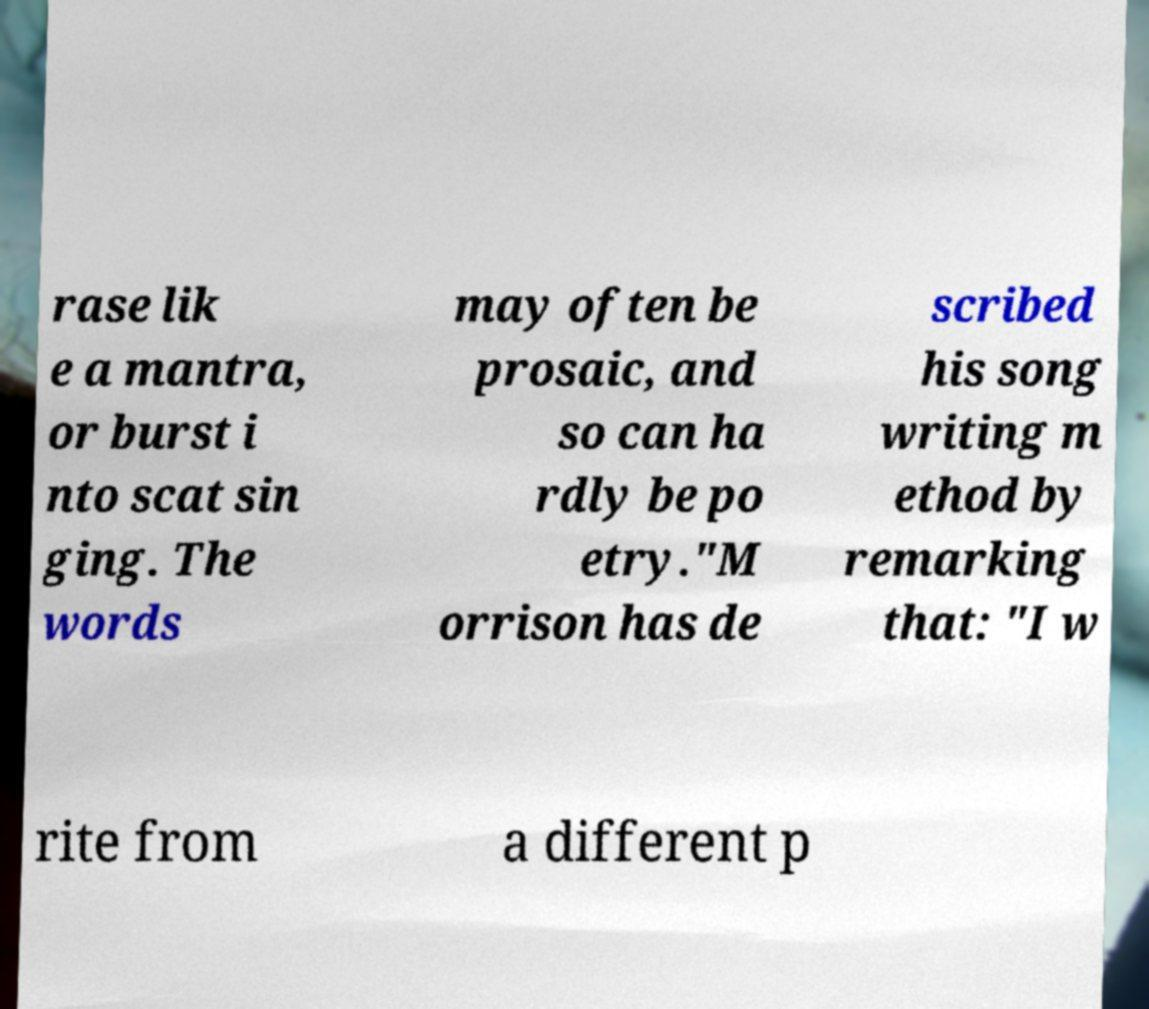Can you read and provide the text displayed in the image?This photo seems to have some interesting text. Can you extract and type it out for me? rase lik e a mantra, or burst i nto scat sin ging. The words may often be prosaic, and so can ha rdly be po etry."M orrison has de scribed his song writing m ethod by remarking that: "I w rite from a different p 